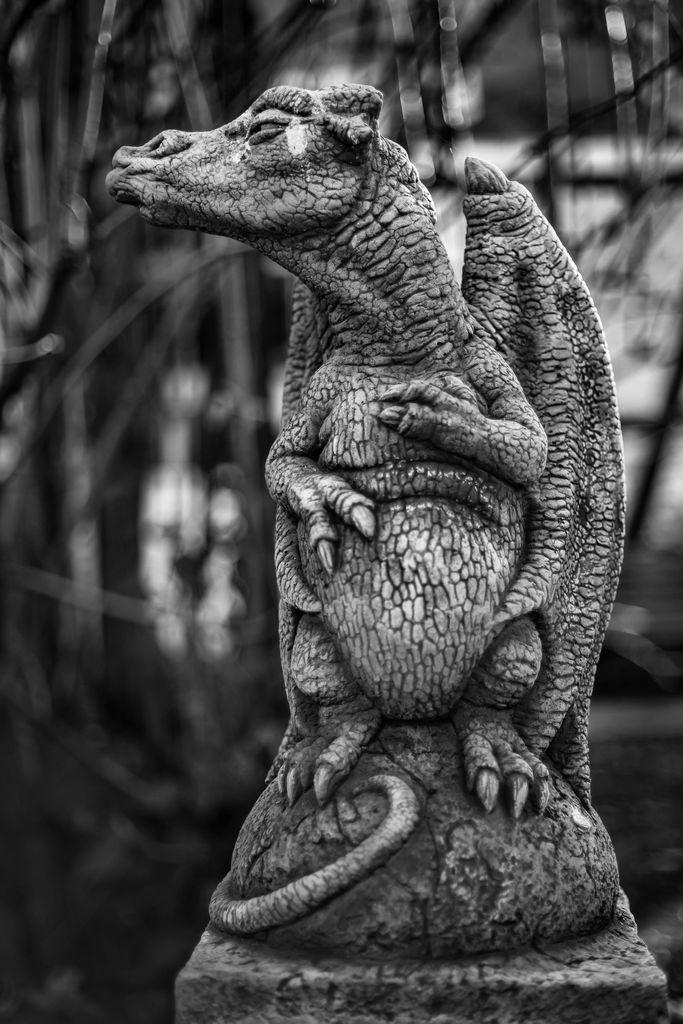What is the main subject of the image? There is a statue of an animal in the image. What is the color of the statue? The statue is black and ash in color. How would you describe the background of the image? The background of the image is blurry. What type of ticket is required to enter the exhibit featuring the statue in the image? There is no information about an exhibit or a ticket in the image, so it cannot be determined from the image. 